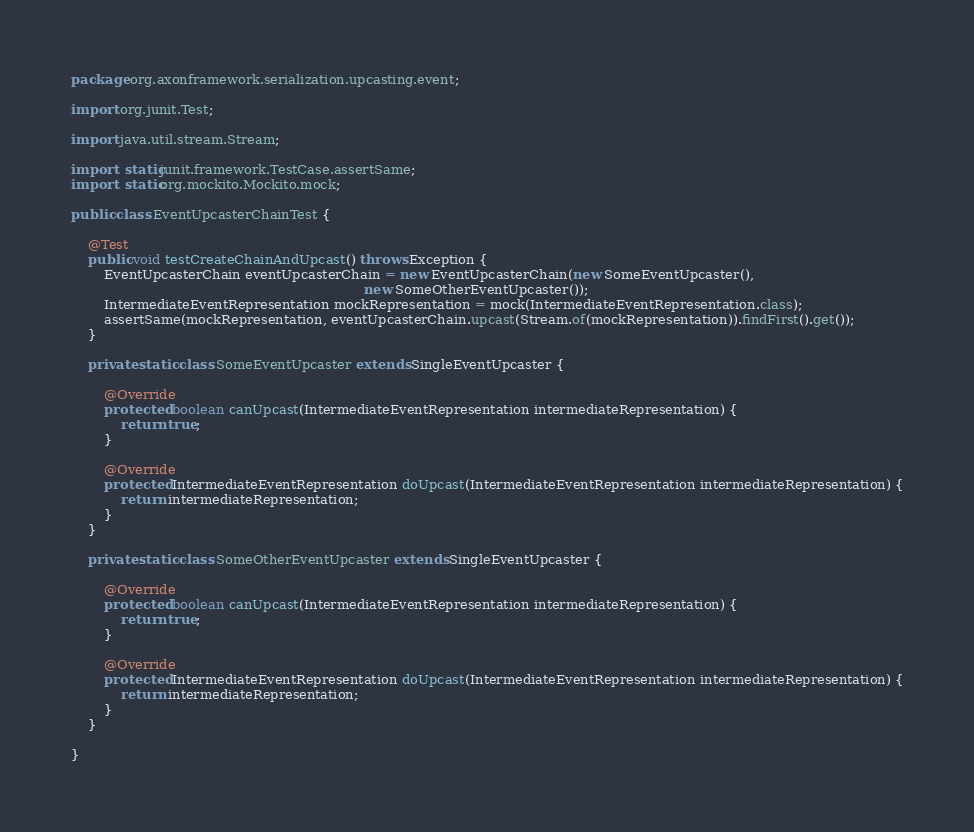<code> <loc_0><loc_0><loc_500><loc_500><_Java_>package org.axonframework.serialization.upcasting.event;

import org.junit.Test;

import java.util.stream.Stream;

import static junit.framework.TestCase.assertSame;
import static org.mockito.Mockito.mock;

public class EventUpcasterChainTest {

    @Test
    public void testCreateChainAndUpcast() throws Exception {
        EventUpcasterChain eventUpcasterChain = new EventUpcasterChain(new SomeEventUpcaster(),
                                                                       new SomeOtherEventUpcaster());
        IntermediateEventRepresentation mockRepresentation = mock(IntermediateEventRepresentation.class);
        assertSame(mockRepresentation, eventUpcasterChain.upcast(Stream.of(mockRepresentation)).findFirst().get());
    }

    private static class SomeEventUpcaster extends SingleEventUpcaster {

        @Override
        protected boolean canUpcast(IntermediateEventRepresentation intermediateRepresentation) {
            return true;
        }

        @Override
        protected IntermediateEventRepresentation doUpcast(IntermediateEventRepresentation intermediateRepresentation) {
            return intermediateRepresentation;
        }
    }

    private static class SomeOtherEventUpcaster extends SingleEventUpcaster {

        @Override
        protected boolean canUpcast(IntermediateEventRepresentation intermediateRepresentation) {
            return true;
        }

        @Override
        protected IntermediateEventRepresentation doUpcast(IntermediateEventRepresentation intermediateRepresentation) {
            return intermediateRepresentation;
        }
    }

}
</code> 